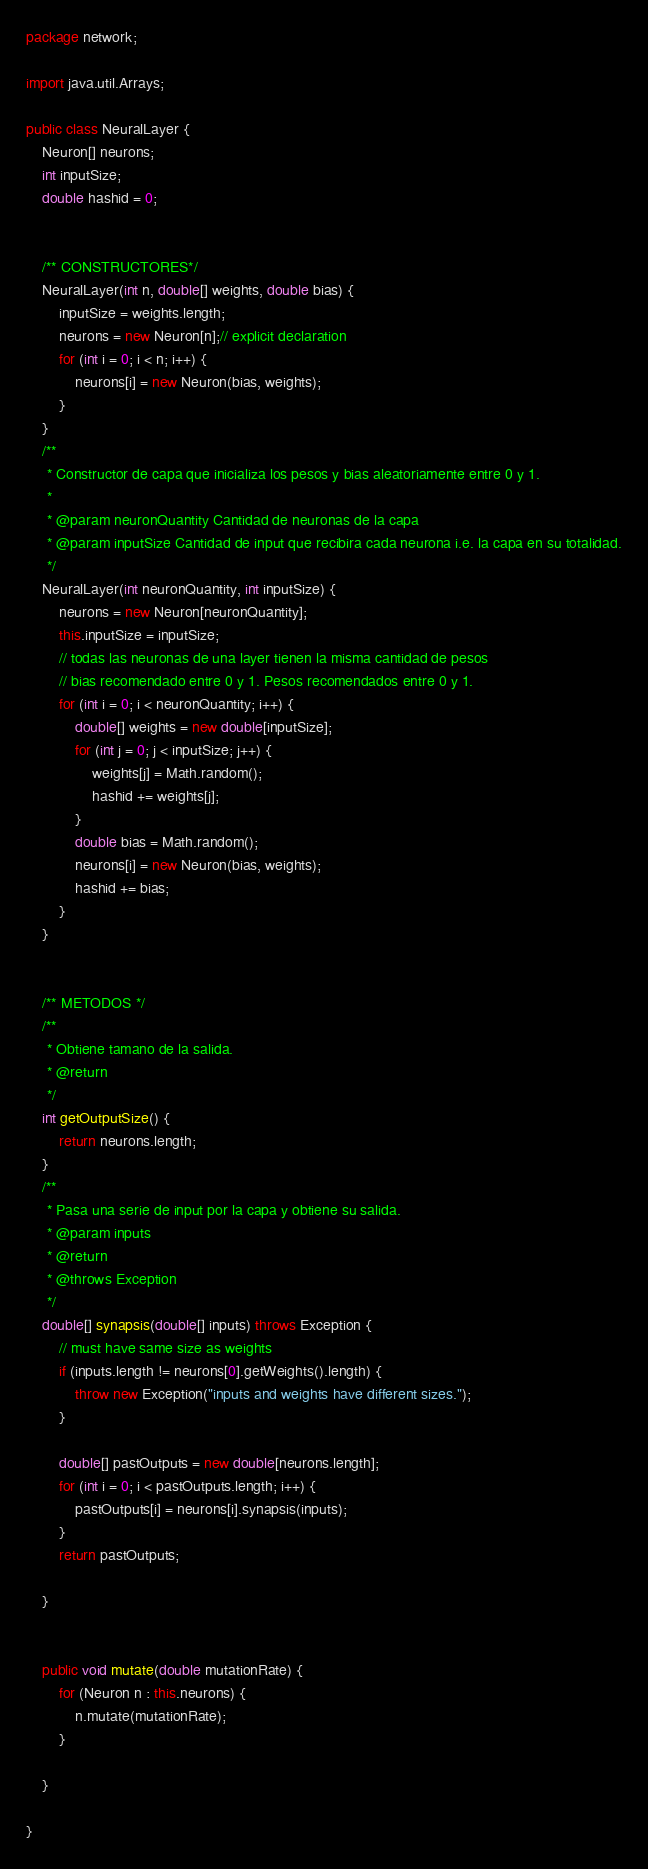<code> <loc_0><loc_0><loc_500><loc_500><_Java_>package network;

import java.util.Arrays;

public class NeuralLayer {
	Neuron[] neurons;
	int inputSize;
	double hashid = 0;
	
	
	/** CONSTRUCTORES*/
	NeuralLayer(int n, double[] weights, double bias) {
		inputSize = weights.length;
		neurons = new Neuron[n];// explicit declaration
		for (int i = 0; i < n; i++) {
			neurons[i] = new Neuron(bias, weights);
		}
	}
	/**
	 * Constructor de capa que inicializa los pesos y bias aleatoriamente entre 0 y 1.
	 * 
	 * @param neuronQuantity Cantidad de neuronas de la capa
	 * @param inputSize Cantidad de input que recibira cada neurona i.e. la capa en su totalidad.
	 */
	NeuralLayer(int neuronQuantity, int inputSize) {
		neurons = new Neuron[neuronQuantity];
		this.inputSize = inputSize;
		// todas las neuronas de una layer tienen la misma cantidad de pesos
		// bias recomendado entre 0 y 1. Pesos recomendados entre 0 y 1.
		for (int i = 0; i < neuronQuantity; i++) {
			double[] weights = new double[inputSize];
			for (int j = 0; j < inputSize; j++) {
				weights[j] = Math.random();
				hashid += weights[j];
			}
			double bias = Math.random();
			neurons[i] = new Neuron(bias, weights);
			hashid += bias;
		}
	}

	
	/** METODOS */
	/**
	 * Obtiene tamano de la salida.
	 * @return
	 */
	int getOutputSize() {
		return neurons.length;
	}
	/**
	 * Pasa una serie de input por la capa y obtiene su salida.
	 * @param inputs
	 * @return
	 * @throws Exception
	 */
	double[] synapsis(double[] inputs) throws Exception {
		// must have same size as weights
		if (inputs.length != neurons[0].getWeights().length) {
			throw new Exception("inputs and weights have different sizes.");
		}
		
		double[] pastOutputs = new double[neurons.length];
		for (int i = 0; i < pastOutputs.length; i++) {
			pastOutputs[i] = neurons[i].synapsis(inputs);
		}
		return pastOutputs;
		
	}

	
	public void mutate(double mutationRate) {
		for (Neuron n : this.neurons) {
			n.mutate(mutationRate);
		}
		
	}

}
</code> 